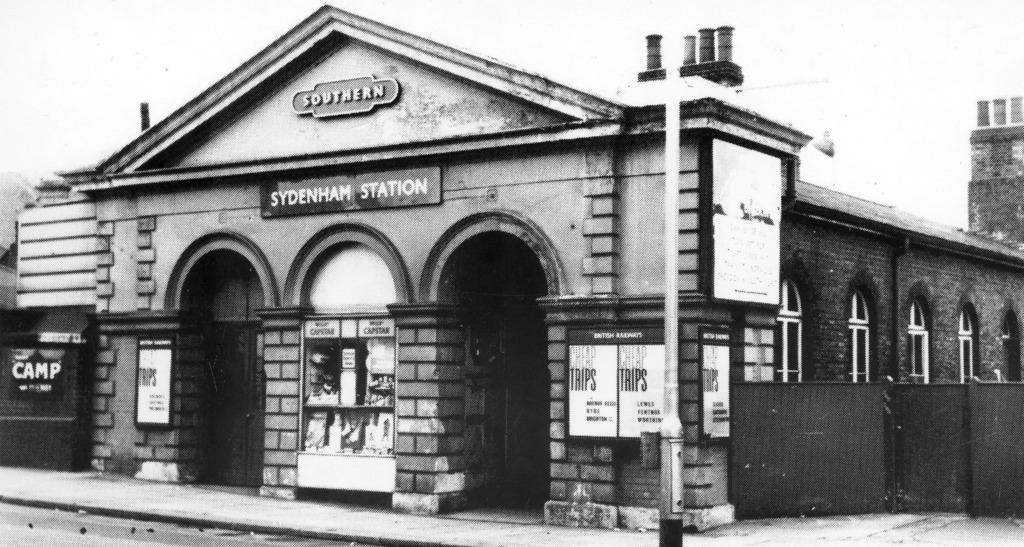What is the color scheme of the image? The image is black and white. What type of path can be seen in the image? There is a footpath in the image. What structure is present in the image? There is a pole in the image. What type of signage is visible in the image? Name boards are present in the image. What type of printed material is visible in the image? Posters are visible in the image. What type of building is present in the image? There is a building with windows in the image. What other objects can be seen in the image? There are some objects in the image. Can you tell me how many crooks are sitting on the sofa in the image? There is no sofa or crooks present in the image. What type of order is being followed by the objects in the image? The image does not depict any specific order or arrangement of objects. 